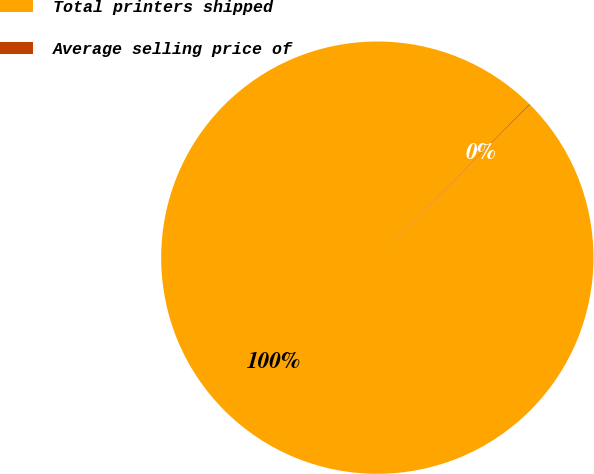Convert chart. <chart><loc_0><loc_0><loc_500><loc_500><pie_chart><fcel>Total printers shipped<fcel>Average selling price of<nl><fcel>99.94%<fcel>0.06%<nl></chart> 